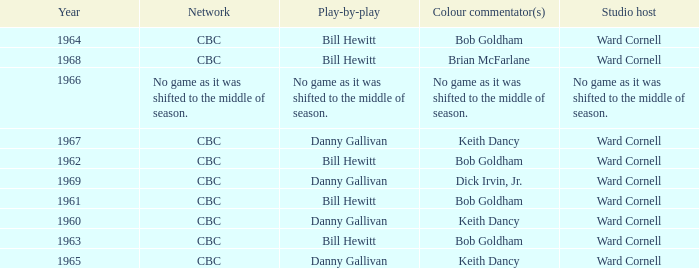Were the color commentators who worked with Bill Hewitt doing the play-by-play? Brian McFarlane, Bob Goldham, Bob Goldham, Bob Goldham, Bob Goldham. 